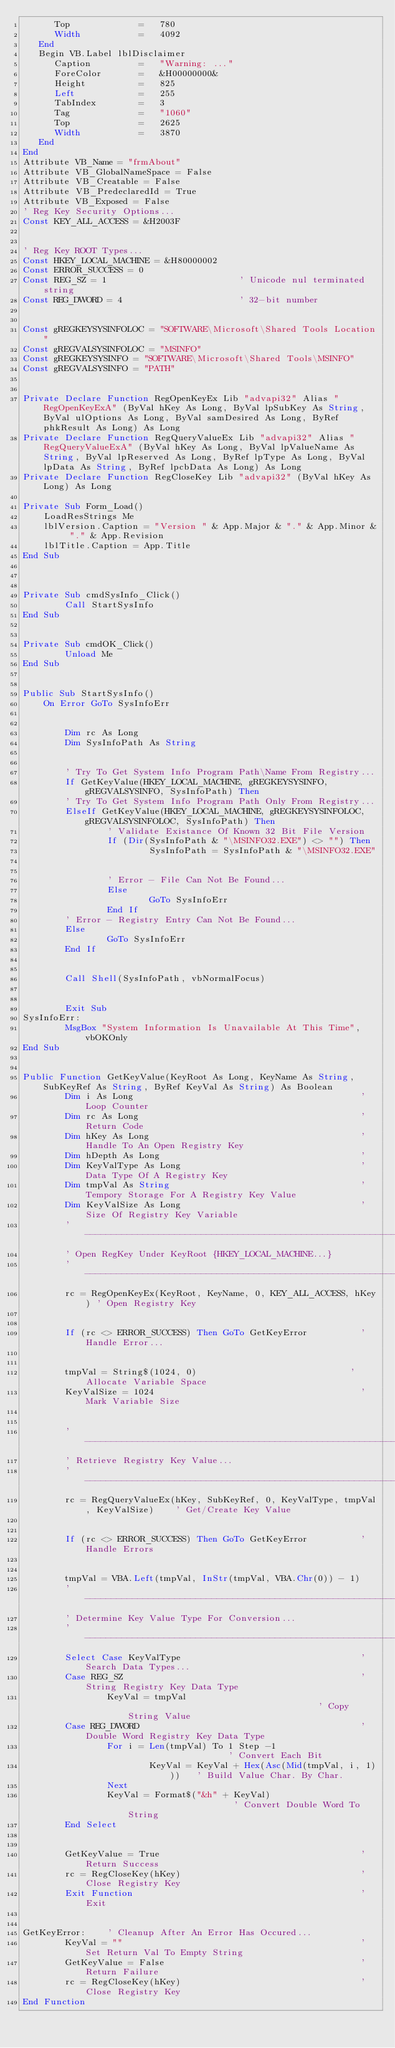<code> <loc_0><loc_0><loc_500><loc_500><_VisualBasic_>      Top             =   780
      Width           =   4092
   End
   Begin VB.Label lblDisclaimer 
      Caption         =   "Warning: ..."
      ForeColor       =   &H00000000&
      Height          =   825
      Left            =   255
      TabIndex        =   3
      Tag             =   "1060"
      Top             =   2625
      Width           =   3870
   End
End
Attribute VB_Name = "frmAbout"
Attribute VB_GlobalNameSpace = False
Attribute VB_Creatable = False
Attribute VB_PredeclaredId = True
Attribute VB_Exposed = False
' Reg Key Security Options...
Const KEY_ALL_ACCESS = &H2003F
                                          

' Reg Key ROOT Types...
Const HKEY_LOCAL_MACHINE = &H80000002
Const ERROR_SUCCESS = 0
Const REG_SZ = 1                         ' Unicode nul terminated string
Const REG_DWORD = 4                      ' 32-bit number


Const gREGKEYSYSINFOLOC = "SOFTWARE\Microsoft\Shared Tools Location"
Const gREGVALSYSINFOLOC = "MSINFO"
Const gREGKEYSYSINFO = "SOFTWARE\Microsoft\Shared Tools\MSINFO"
Const gREGVALSYSINFO = "PATH"


Private Declare Function RegOpenKeyEx Lib "advapi32" Alias "RegOpenKeyExA" (ByVal hKey As Long, ByVal lpSubKey As String, ByVal ulOptions As Long, ByVal samDesired As Long, ByRef phkResult As Long) As Long
Private Declare Function RegQueryValueEx Lib "advapi32" Alias "RegQueryValueExA" (ByVal hKey As Long, ByVal lpValueName As String, ByVal lpReserved As Long, ByRef lpType As Long, ByVal lpData As String, ByRef lpcbData As Long) As Long
Private Declare Function RegCloseKey Lib "advapi32" (ByVal hKey As Long) As Long

Private Sub Form_Load()
    LoadResStrings Me
    lblVersion.Caption = "Version " & App.Major & "." & App.Minor & "." & App.Revision
    lblTitle.Caption = App.Title
End Sub



Private Sub cmdSysInfo_Click()
        Call StartSysInfo
End Sub


Private Sub cmdOK_Click()
        Unload Me
End Sub


Public Sub StartSysInfo()
    On Error GoTo SysInfoErr


        Dim rc As Long
        Dim SysInfoPath As String
        

        ' Try To Get System Info Program Path\Name From Registry...
        If GetKeyValue(HKEY_LOCAL_MACHINE, gREGKEYSYSINFO, gREGVALSYSINFO, SysInfoPath) Then
        ' Try To Get System Info Program Path Only From Registry...
        ElseIf GetKeyValue(HKEY_LOCAL_MACHINE, gREGKEYSYSINFOLOC, gREGVALSYSINFOLOC, SysInfoPath) Then
                ' Validate Existance Of Known 32 Bit File Version
                If (Dir(SysInfoPath & "\MSINFO32.EXE") <> "") Then
                        SysInfoPath = SysInfoPath & "\MSINFO32.EXE"
                        

                ' Error - File Can Not Be Found...
                Else
                        GoTo SysInfoErr
                End If
        ' Error - Registry Entry Can Not Be Found...
        Else
                GoTo SysInfoErr
        End If
        

        Call Shell(SysInfoPath, vbNormalFocus)
        

        Exit Sub
SysInfoErr:
        MsgBox "System Information Is Unavailable At This Time", vbOKOnly
End Sub


Public Function GetKeyValue(KeyRoot As Long, KeyName As String, SubKeyRef As String, ByRef KeyVal As String) As Boolean
        Dim i As Long                                           ' Loop Counter
        Dim rc As Long                                          ' Return Code
        Dim hKey As Long                                        ' Handle To An Open Registry Key
        Dim hDepth As Long                                      '
        Dim KeyValType As Long                                  ' Data Type Of A Registry Key
        Dim tmpVal As String                                    ' Tempory Storage For A Registry Key Value
        Dim KeyValSize As Long                                  ' Size Of Registry Key Variable
        '------------------------------------------------------------
        ' Open RegKey Under KeyRoot {HKEY_LOCAL_MACHINE...}
        '------------------------------------------------------------
        rc = RegOpenKeyEx(KeyRoot, KeyName, 0, KEY_ALL_ACCESS, hKey) ' Open Registry Key
        

        If (rc <> ERROR_SUCCESS) Then GoTo GetKeyError          ' Handle Error...
        

        tmpVal = String$(1024, 0)                             ' Allocate Variable Space
        KeyValSize = 1024                                       ' Mark Variable Size
        

        '------------------------------------------------------------
        ' Retrieve Registry Key Value...
        '------------------------------------------------------------
        rc = RegQueryValueEx(hKey, SubKeyRef, 0, KeyValType, tmpVal, KeyValSize)    ' Get/Create Key Value
                                                

        If (rc <> ERROR_SUCCESS) Then GoTo GetKeyError          ' Handle Errors
        

        tmpVal = VBA.Left(tmpVal, InStr(tmpVal, VBA.Chr(0)) - 1)
        '------------------------------------------------------------
        ' Determine Key Value Type For Conversion...
        '------------------------------------------------------------
        Select Case KeyValType                                  ' Search Data Types...
        Case REG_SZ                                             ' String Registry Key Data Type
                KeyVal = tmpVal                                     ' Copy String Value
        Case REG_DWORD                                          ' Double Word Registry Key Data Type
                For i = Len(tmpVal) To 1 Step -1                    ' Convert Each Bit
                        KeyVal = KeyVal + Hex(Asc(Mid(tmpVal, i, 1)))   ' Build Value Char. By Char.
                Next
                KeyVal = Format$("&h" + KeyVal)                     ' Convert Double Word To String
        End Select
        

        GetKeyValue = True                                      ' Return Success
        rc = RegCloseKey(hKey)                                  ' Close Registry Key
        Exit Function                                           ' Exit
        

GetKeyError:    ' Cleanup After An Error Has Occured...
        KeyVal = ""                                             ' Set Return Val To Empty String
        GetKeyValue = False                                     ' Return Failure
        rc = RegCloseKey(hKey)                                  ' Close Registry Key
End Function

</code> 